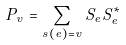Convert formula to latex. <formula><loc_0><loc_0><loc_500><loc_500>P _ { v } = \sum _ { s ( e ) = v } S _ { e } S _ { e } ^ { * }</formula> 